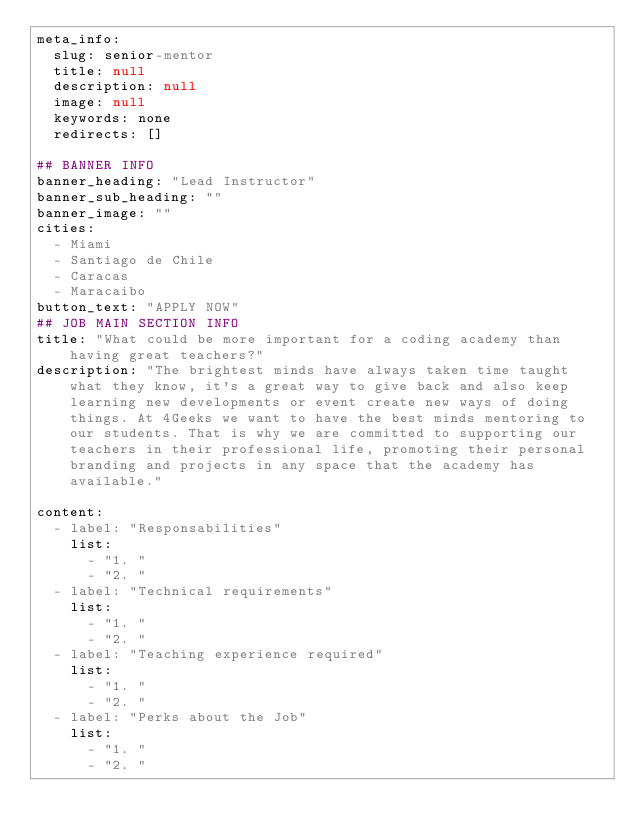Convert code to text. <code><loc_0><loc_0><loc_500><loc_500><_YAML_>meta_info:
  slug: senior-mentor
  title: null
  description: null
  image: null
  keywords: none
  redirects: []

## BANNER INFO
banner_heading: "Lead Instructor"
banner_sub_heading: ""
banner_image: ""
cities:
  - Miami
  - Santiago de Chile
  - Caracas
  - Maracaibo
button_text: "APPLY NOW"
## JOB MAIN SECTION INFO
title: "What could be more important for a coding academy than having great teachers?"
description: "The brightest minds have always taken time taught what they know, it's a great way to give back and also keep learning new developments or event create new ways of doing things. At 4Geeks we want to have the best minds mentoring to our students. That is why we are committed to supporting our teachers in their professional life, promoting their personal branding and projects in any space that the academy has available."

content:
  - label: "Responsabilities"
    list:
      - "1. "
      - "2. "
  - label: "Technical requirements"
    list:
      - "1. "
      - "2. "
  - label: "Teaching experience required"
    list:
      - "1. "
      - "2. "
  - label: "Perks about the Job"
    list:
      - "1. "
      - "2. "
</code> 